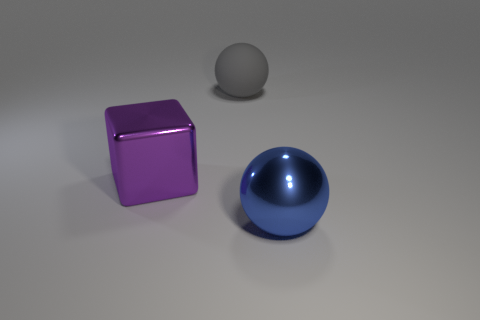Are there an equal number of blue things in front of the large purple metal object and large purple metal things to the left of the big shiny sphere? yes 